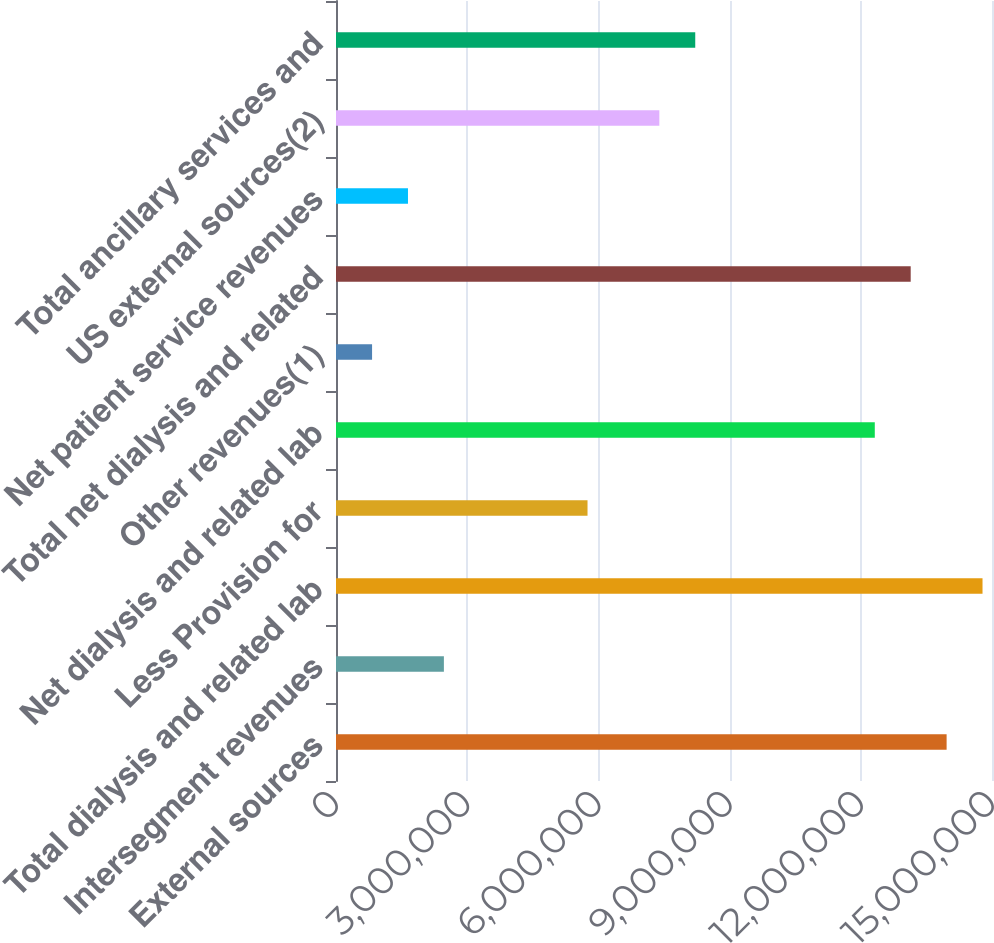<chart> <loc_0><loc_0><loc_500><loc_500><bar_chart><fcel>External sources<fcel>Intersegment revenues<fcel>Total dialysis and related lab<fcel>Less Provision for<fcel>Net dialysis and related lab<fcel>Other revenues(1)<fcel>Total net dialysis and related<fcel>Net patient service revenues<fcel>US external sources(2)<fcel>Total ancillary services and<nl><fcel>1.39621e+07<fcel>2.46698e+06<fcel>1.47832e+07<fcel>5.7513e+06<fcel>1.232e+07<fcel>824818<fcel>1.3141e+07<fcel>1.6459e+06<fcel>7.39347e+06<fcel>8.21455e+06<nl></chart> 